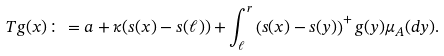<formula> <loc_0><loc_0><loc_500><loc_500>T g ( x ) \colon = a + \kappa ( s ( x ) - s ( \ell ) ) + \int _ { \ell } ^ { r } \left ( s ( x ) - s ( y ) \right ) ^ { + } g ( y ) \mu _ { A } ( d y ) .</formula> 